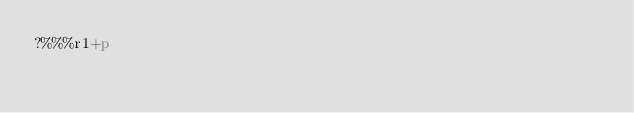Convert code to text. <code><loc_0><loc_0><loc_500><loc_500><_dc_>?%%%r1+p</code> 